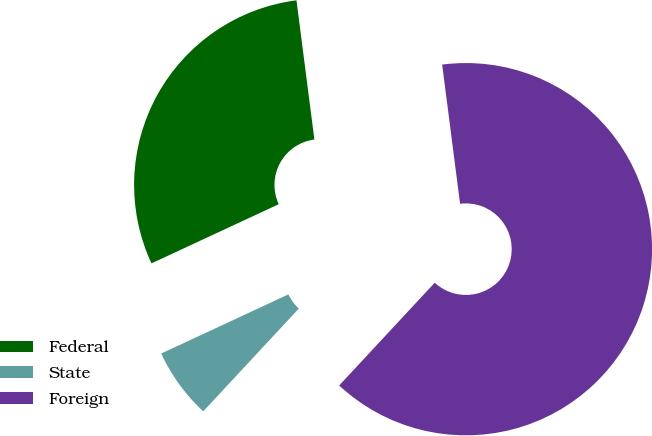Convert chart. <chart><loc_0><loc_0><loc_500><loc_500><pie_chart><fcel>Federal<fcel>State<fcel>Foreign<nl><fcel>29.89%<fcel>6.15%<fcel>63.96%<nl></chart> 